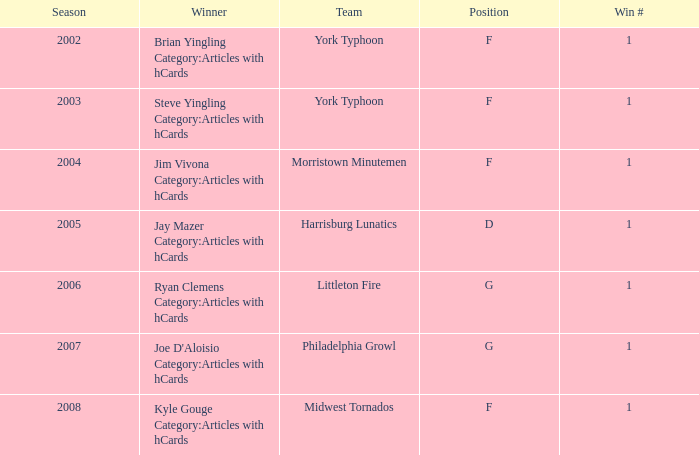Who was the winner in the 2008 season? Kyle Gouge Category:Articles with hCards. 